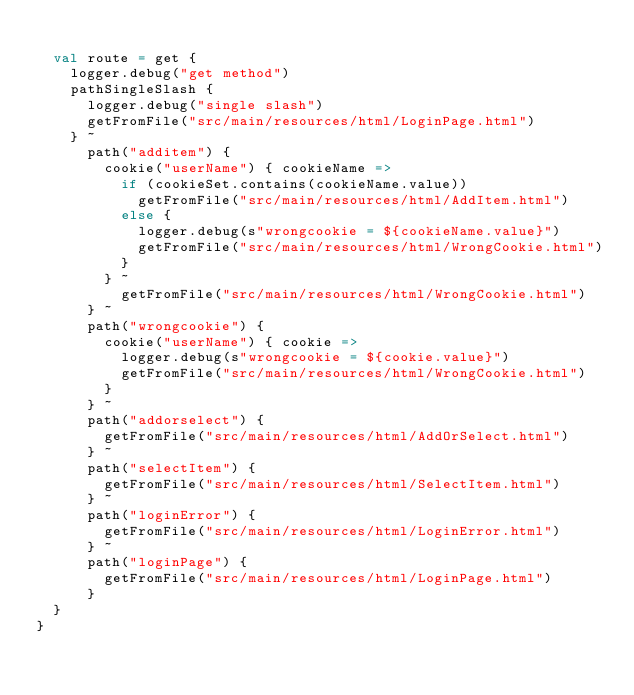<code> <loc_0><loc_0><loc_500><loc_500><_Scala_>
  val route = get {
    logger.debug("get method")
    pathSingleSlash {
      logger.debug("single slash")
      getFromFile("src/main/resources/html/LoginPage.html")
    } ~
      path("additem") {
        cookie("userName") { cookieName =>
          if (cookieSet.contains(cookieName.value))
            getFromFile("src/main/resources/html/AddItem.html")
          else {
            logger.debug(s"wrongcookie = ${cookieName.value}")
            getFromFile("src/main/resources/html/WrongCookie.html")
          }
        } ~
          getFromFile("src/main/resources/html/WrongCookie.html")
      } ~
      path("wrongcookie") {
        cookie("userName") { cookie =>
          logger.debug(s"wrongcookie = ${cookie.value}")
          getFromFile("src/main/resources/html/WrongCookie.html")
        }
      } ~
      path("addorselect") {
        getFromFile("src/main/resources/html/AddOrSelect.html")
      } ~
      path("selectItem") {
        getFromFile("src/main/resources/html/SelectItem.html")
      } ~
      path("loginError") {
        getFromFile("src/main/resources/html/LoginError.html")
      } ~
      path("loginPage") {
        getFromFile("src/main/resources/html/LoginPage.html")
      }
  }
}
</code> 